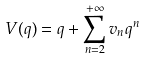<formula> <loc_0><loc_0><loc_500><loc_500>V ( q ) = q + \sum _ { n = 2 } ^ { + \infty } v _ { n } q ^ { n }</formula> 